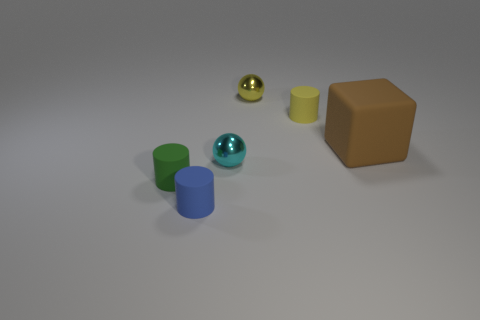What material is the tiny object to the left of the blue matte cylinder? The tiny object to the left of the blue matte cylinder appears to be a small sphere with a shiny, metallic surface, which suggests that it could be made of metal rather than rubber. However, without being able to physically examine the object or having more context, it is challenging to determine the specific material with certainty. 